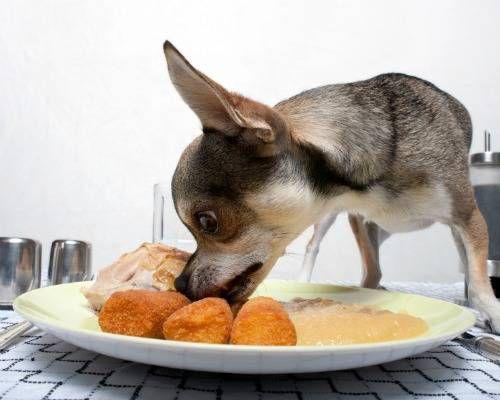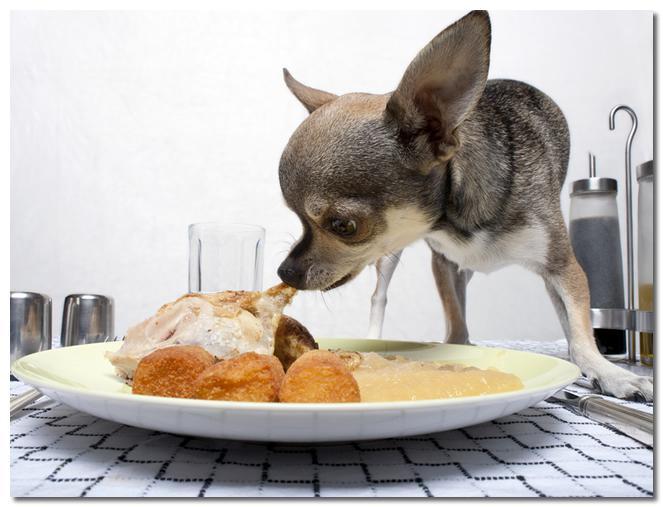The first image is the image on the left, the second image is the image on the right. Given the left and right images, does the statement "At least one image shows a single dog standing behind a white plate with multiple food items on it." hold true? Answer yes or no. Yes. The first image is the image on the left, the second image is the image on the right. Assess this claim about the two images: "Two dogs are shown standing near food.". Correct or not? Answer yes or no. Yes. 